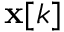Convert formula to latex. <formula><loc_0><loc_0><loc_500><loc_500>x [ k ]</formula> 